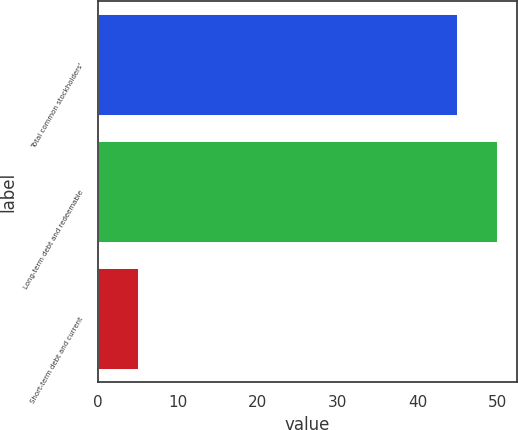Convert chart. <chart><loc_0><loc_0><loc_500><loc_500><bar_chart><fcel>Total common stockholders'<fcel>Long-term debt and redeemable<fcel>Short-term debt and current<nl><fcel>45<fcel>50<fcel>5<nl></chart> 